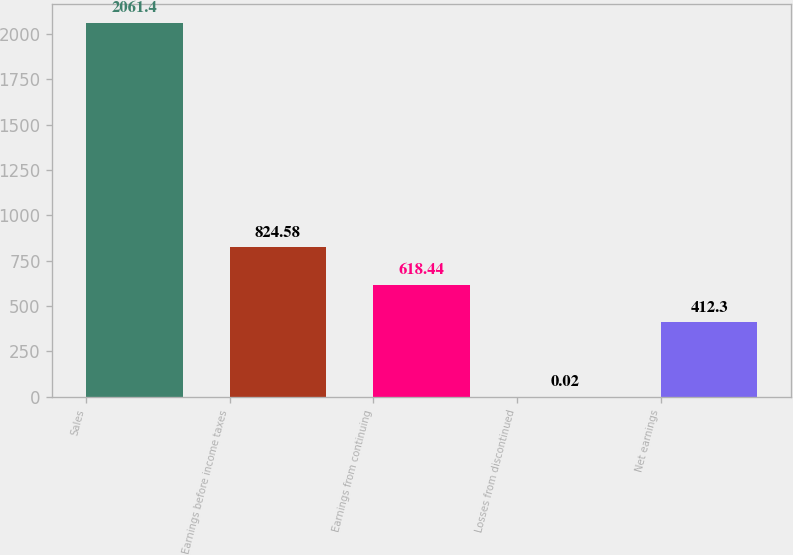Convert chart to OTSL. <chart><loc_0><loc_0><loc_500><loc_500><bar_chart><fcel>Sales<fcel>Earnings before income taxes<fcel>Earnings from continuing<fcel>Losses from discontinued<fcel>Net earnings<nl><fcel>2061.4<fcel>824.58<fcel>618.44<fcel>0.02<fcel>412.3<nl></chart> 